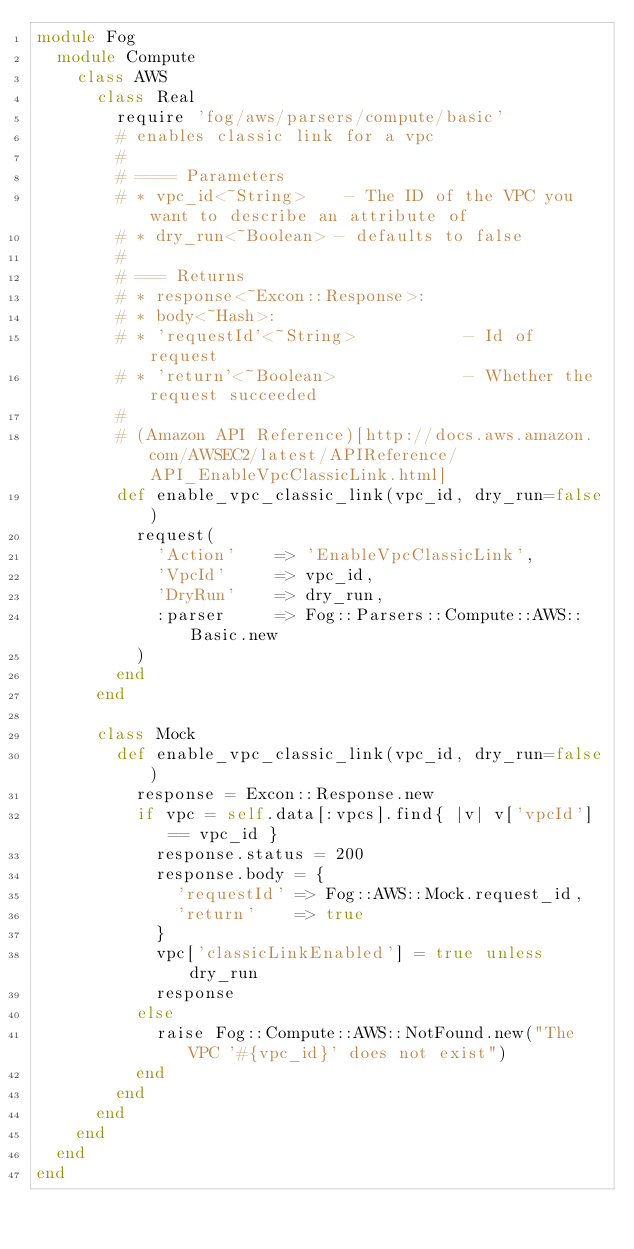Convert code to text. <code><loc_0><loc_0><loc_500><loc_500><_Ruby_>module Fog
  module Compute
    class AWS
      class Real
        require 'fog/aws/parsers/compute/basic'
        # enables classic link for a vpc
        #
        # ==== Parameters
        # * vpc_id<~String>    - The ID of the VPC you want to describe an attribute of
        # * dry_run<~Boolean> - defaults to false
        #
        # === Returns
        # * response<~Excon::Response>:
        # * body<~Hash>:
        # * 'requestId'<~String>           - Id of request
        # * 'return'<~Boolean>             - Whether the request succeeded
        #
        # (Amazon API Reference)[http://docs.aws.amazon.com/AWSEC2/latest/APIReference/API_EnableVpcClassicLink.html]
        def enable_vpc_classic_link(vpc_id, dry_run=false)
          request(
            'Action'    => 'EnableVpcClassicLink',
            'VpcId'     => vpc_id,
            'DryRun'    => dry_run,
            :parser     => Fog::Parsers::Compute::AWS::Basic.new
          )
        end
      end

      class Mock
        def enable_vpc_classic_link(vpc_id, dry_run=false)
          response = Excon::Response.new
          if vpc = self.data[:vpcs].find{ |v| v['vpcId'] == vpc_id }
            response.status = 200
            response.body = {
              'requestId' => Fog::AWS::Mock.request_id,
              'return'    => true
            }
            vpc['classicLinkEnabled'] = true unless dry_run
            response
          else
            raise Fog::Compute::AWS::NotFound.new("The VPC '#{vpc_id}' does not exist")
          end
        end
      end
    end
  end
end
</code> 